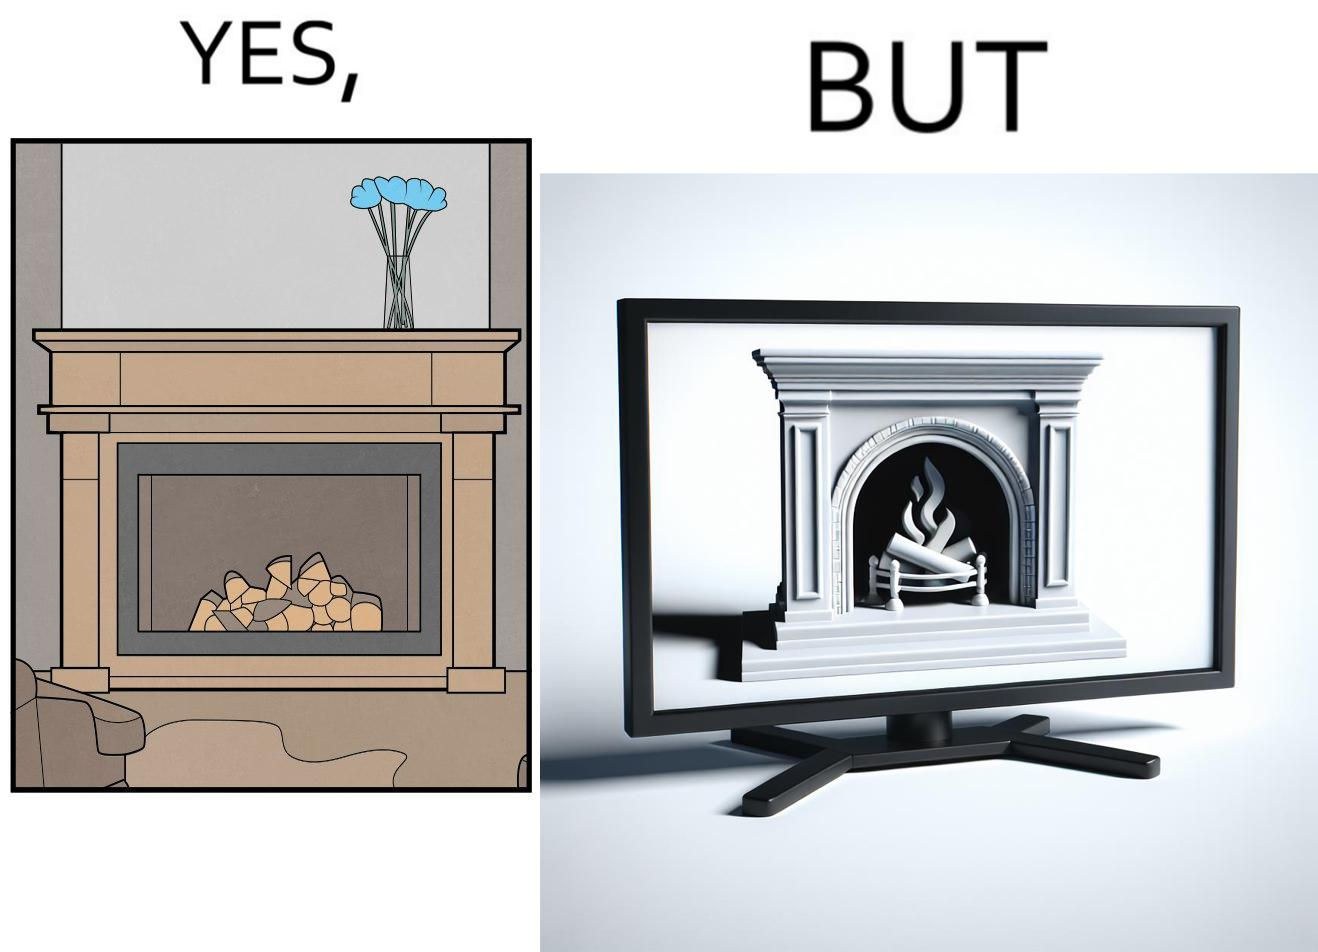Describe what you see in the left and right parts of this image. In the left part of the image: It is a fireplace In the right part of the image: It a fireplace being displayed on a television screen 